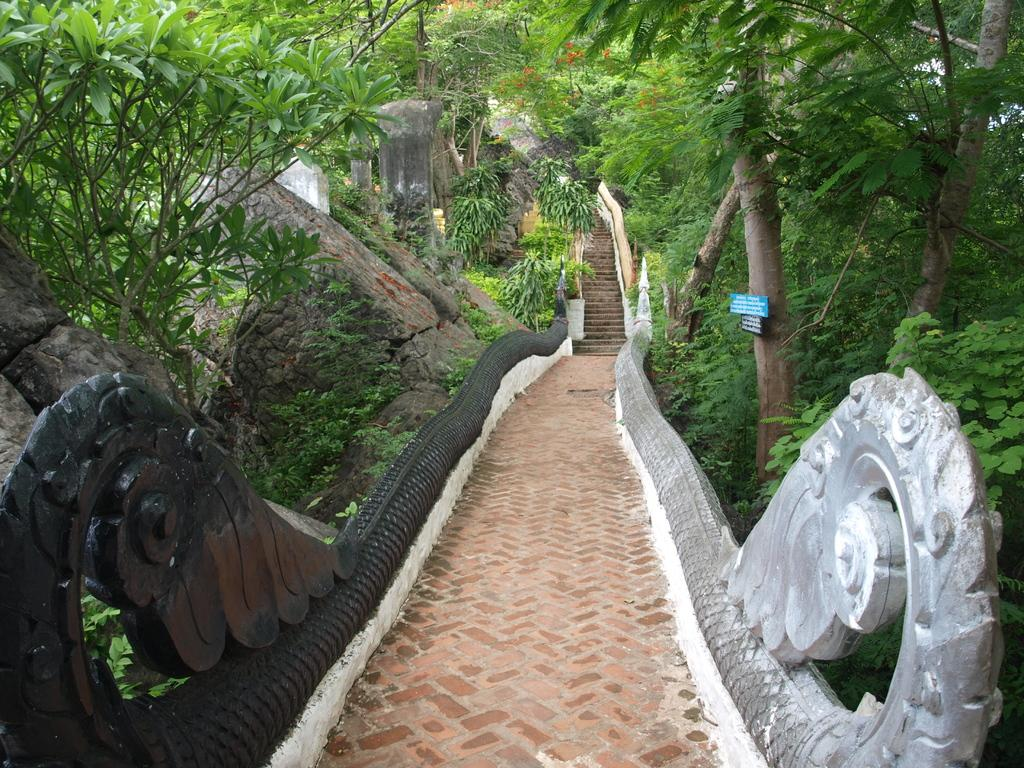What type of structure is present in the image? There are stairs in the image. Is there any safety feature associated with the stairs? Yes, there is a railing in the image. What type of natural elements can be seen in the image? There are trees in the image. Can you describe the tree on the right side of the image? There is a tree with boards on the right side of the image. What other natural elements are present on the left side of the image? There are trees and rocks on the left side of the image. What type of glass is used to make the pies in the image? There are no pies present in the image, so it is not possible to determine the type of glass used to make them. 